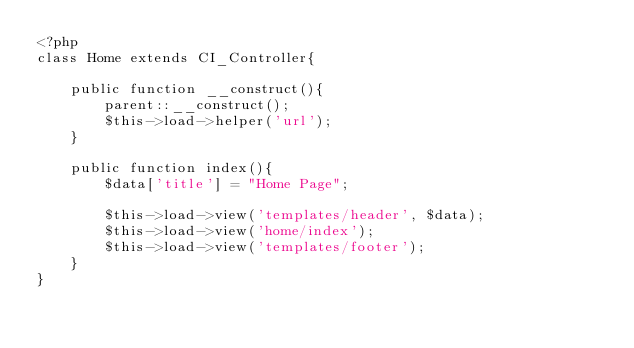Convert code to text. <code><loc_0><loc_0><loc_500><loc_500><_PHP_><?php
class Home extends CI_Controller{

    public function __construct(){
        parent::__construct();
        $this->load->helper('url');
    }

    public function index(){
        $data['title'] = "Home Page";

        $this->load->view('templates/header', $data);
        $this->load->view('home/index');
        $this->load->view('templates/footer');
    }
}</code> 